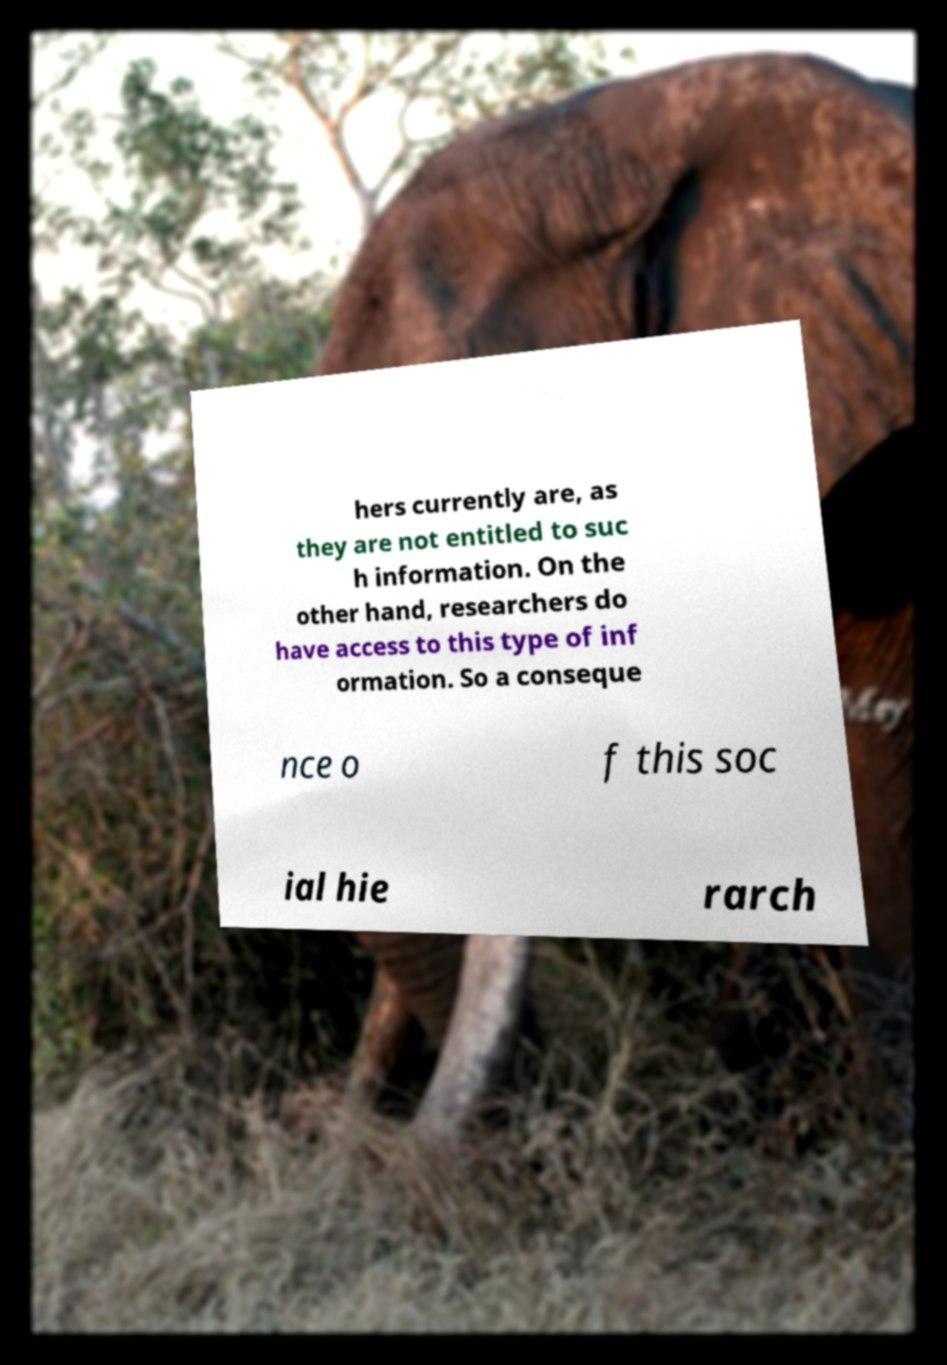Could you assist in decoding the text presented in this image and type it out clearly? hers currently are, as they are not entitled to suc h information. On the other hand, researchers do have access to this type of inf ormation. So a conseque nce o f this soc ial hie rarch 